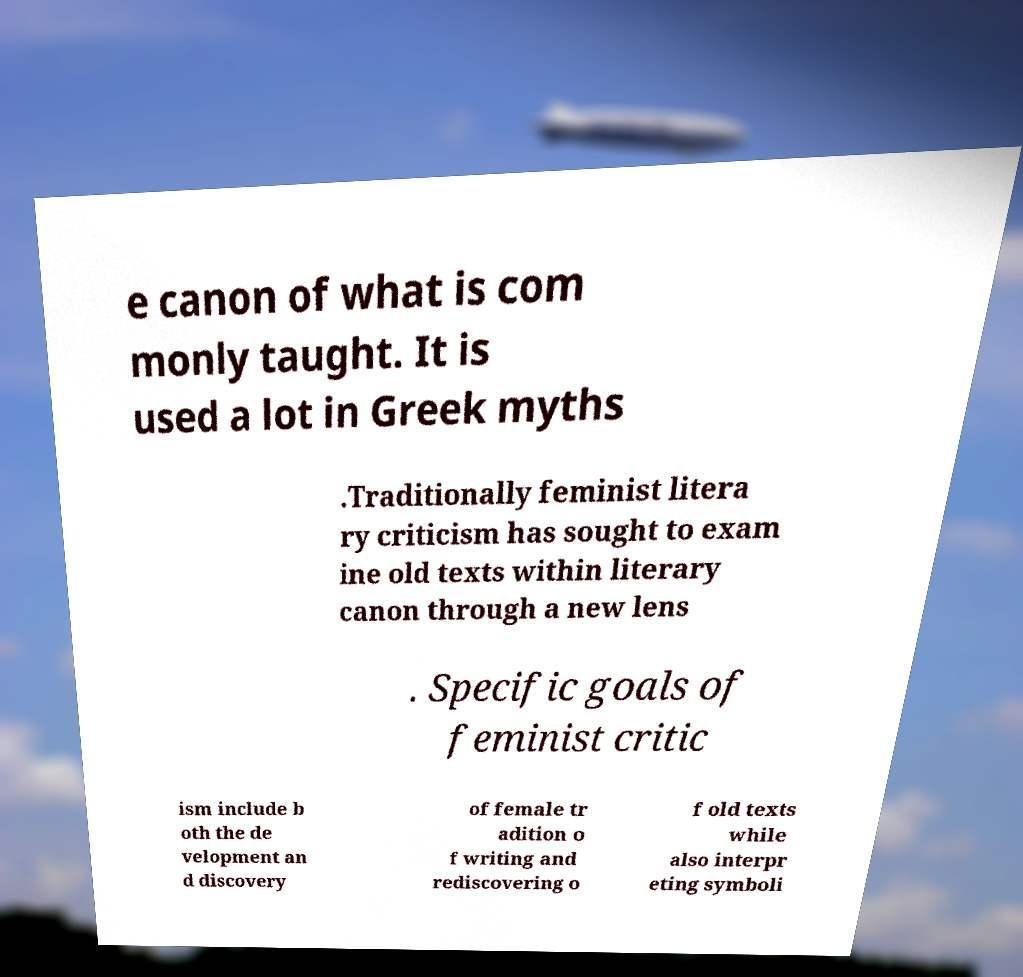Can you read and provide the text displayed in the image?This photo seems to have some interesting text. Can you extract and type it out for me? e canon of what is com monly taught. It is used a lot in Greek myths .Traditionally feminist litera ry criticism has sought to exam ine old texts within literary canon through a new lens . Specific goals of feminist critic ism include b oth the de velopment an d discovery of female tr adition o f writing and rediscovering o f old texts while also interpr eting symboli 